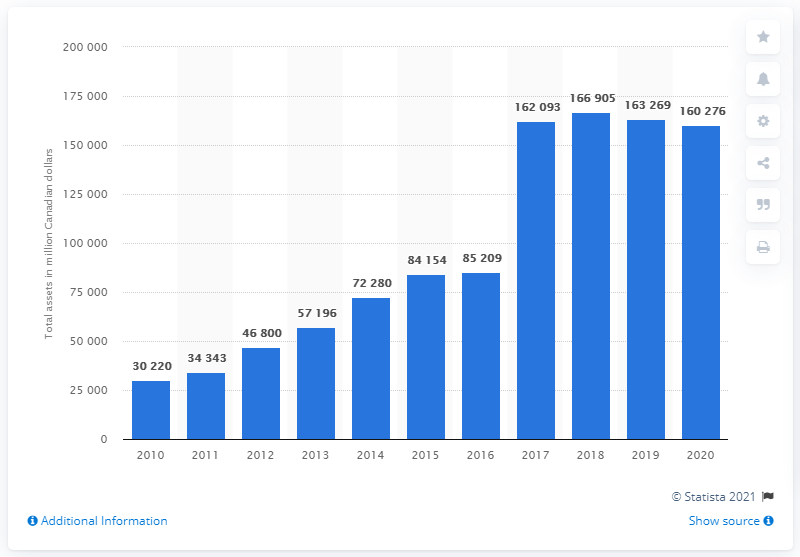Indicate a few pertinent items in this graphic. Enbridge's total assets as of 2020 were worth approximately 160,276. In 2018, Enbridge's assets reached their peak. 